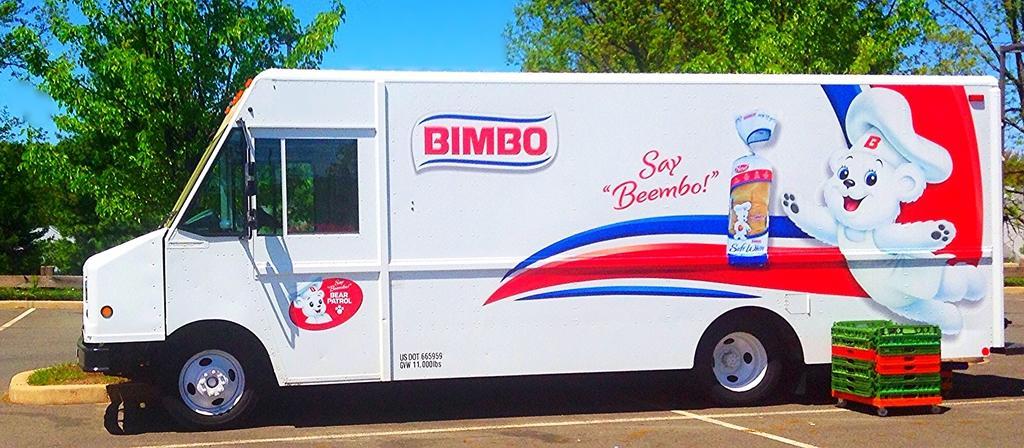Could you give a brief overview of what you see in this image? In front of the picture, we see a vehicle in white color is parked on the road. On the vehicle, it is written as "BIMBO". Beside that, we see blocks in green and red color. At the bottom of the picture, we see the road. There are trees in the background. At the top of the picture, we see the sky. 